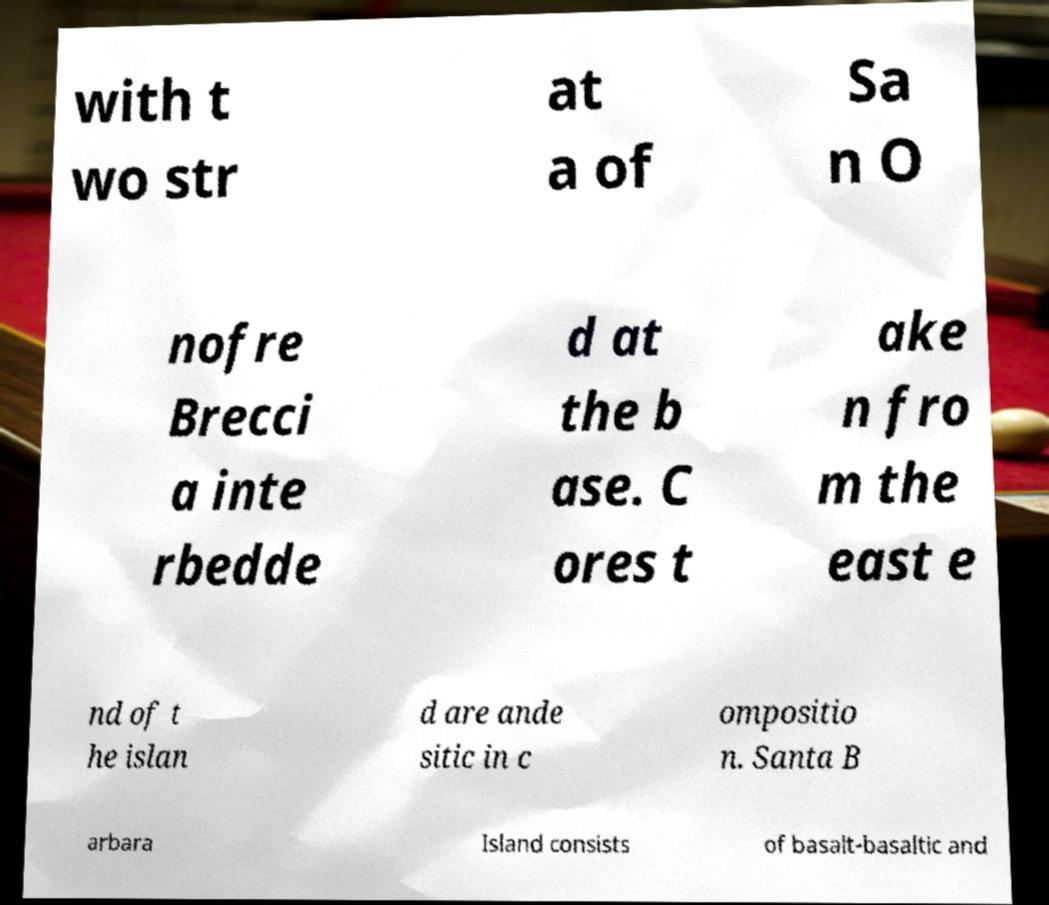What messages or text are displayed in this image? I need them in a readable, typed format. with t wo str at a of Sa n O nofre Brecci a inte rbedde d at the b ase. C ores t ake n fro m the east e nd of t he islan d are ande sitic in c ompositio n. Santa B arbara Island consists of basalt-basaltic and 